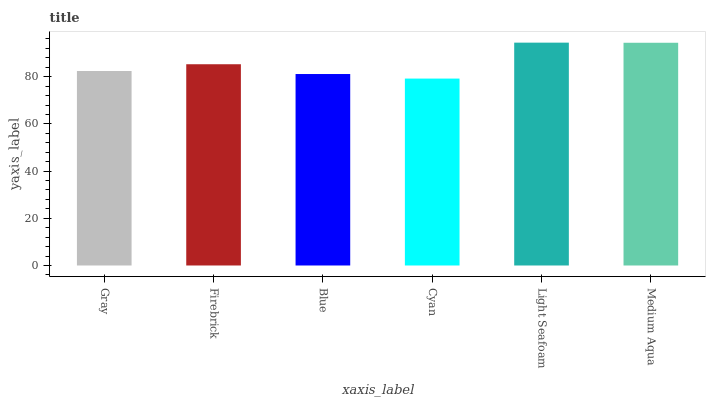Is Cyan the minimum?
Answer yes or no. Yes. Is Light Seafoam the maximum?
Answer yes or no. Yes. Is Firebrick the minimum?
Answer yes or no. No. Is Firebrick the maximum?
Answer yes or no. No. Is Firebrick greater than Gray?
Answer yes or no. Yes. Is Gray less than Firebrick?
Answer yes or no. Yes. Is Gray greater than Firebrick?
Answer yes or no. No. Is Firebrick less than Gray?
Answer yes or no. No. Is Firebrick the high median?
Answer yes or no. Yes. Is Gray the low median?
Answer yes or no. Yes. Is Light Seafoam the high median?
Answer yes or no. No. Is Light Seafoam the low median?
Answer yes or no. No. 